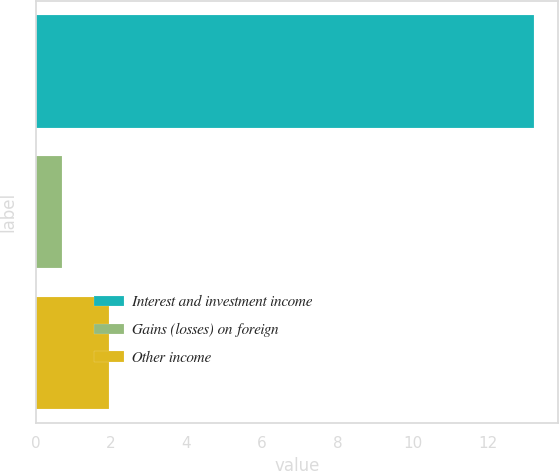Convert chart. <chart><loc_0><loc_0><loc_500><loc_500><bar_chart><fcel>Interest and investment income<fcel>Gains (losses) on foreign<fcel>Other income<nl><fcel>13.2<fcel>0.7<fcel>1.95<nl></chart> 